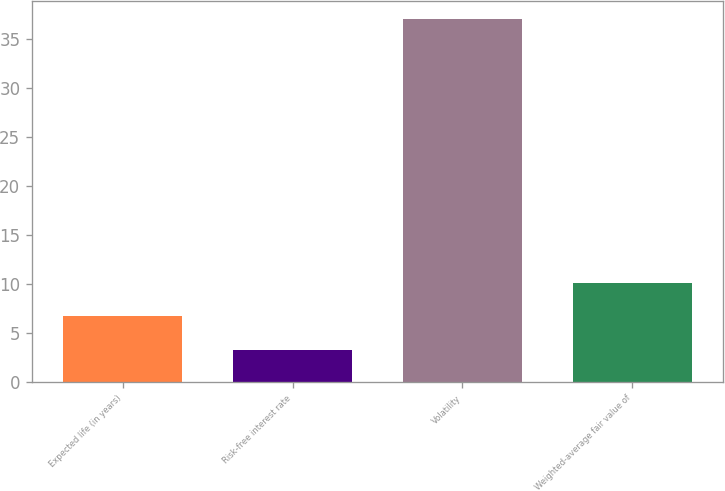<chart> <loc_0><loc_0><loc_500><loc_500><bar_chart><fcel>Expected life (in years)<fcel>Risk-free interest rate<fcel>Volatility<fcel>Weighted-average fair value of<nl><fcel>6.67<fcel>3.3<fcel>37<fcel>10.04<nl></chart> 